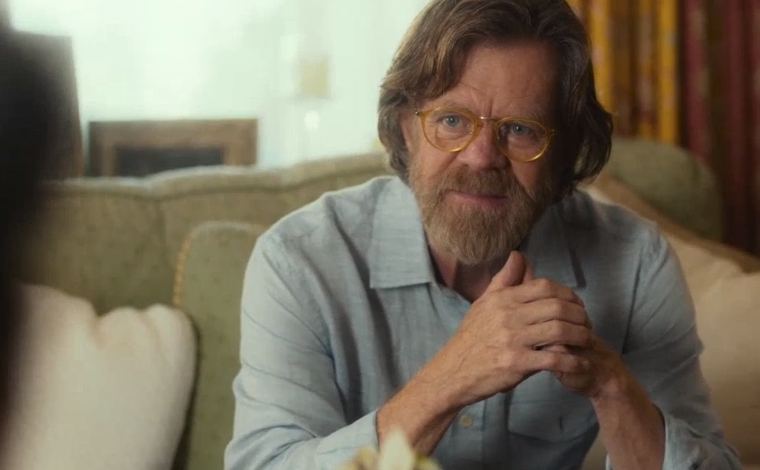Describe the background details of the image. In the background, the image portrays a cozy living room setting. The green armchair the man is sitting on appears plush and comfortable. There's a fireplace visible, adding to the cozy ambiance, although it's not in use at the moment. Curtains with a warm pattern can be seen, casting a warm glow over the room. The lighting is soft and natural, perhaps indicating early morning or late afternoon. What might the man be thinking about? The man's thoughtful expression, combined with his hand gesture and relaxed posture, suggests he might be reflecting on something personal or professional. The serene and comfortable setting could imply he's having a deep, possibly intimate conversation, perhaps discussing life experiences, storytelling, or even contemplating an emotional or intellectual topic. 